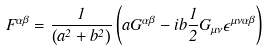<formula> <loc_0><loc_0><loc_500><loc_500>F ^ { \alpha \beta } = \frac { 1 } { \left ( a ^ { 2 } + b ^ { 2 } \right ) } \left ( a G ^ { \alpha \beta } - i b \frac { 1 } { 2 } G _ { \mu \nu } \epsilon ^ { \mu \nu \alpha \beta } \right )</formula> 